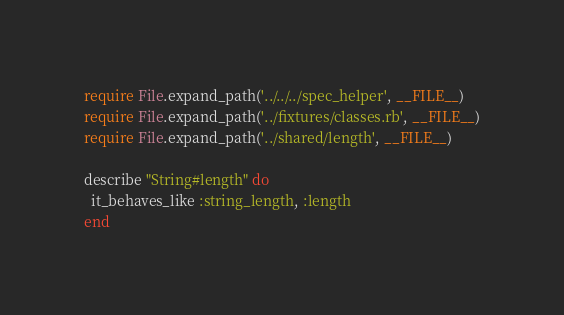<code> <loc_0><loc_0><loc_500><loc_500><_Ruby_>require File.expand_path('../../../spec_helper', __FILE__)
require File.expand_path('../fixtures/classes.rb', __FILE__)
require File.expand_path('../shared/length', __FILE__)

describe "String#length" do
  it_behaves_like :string_length, :length
end
</code> 